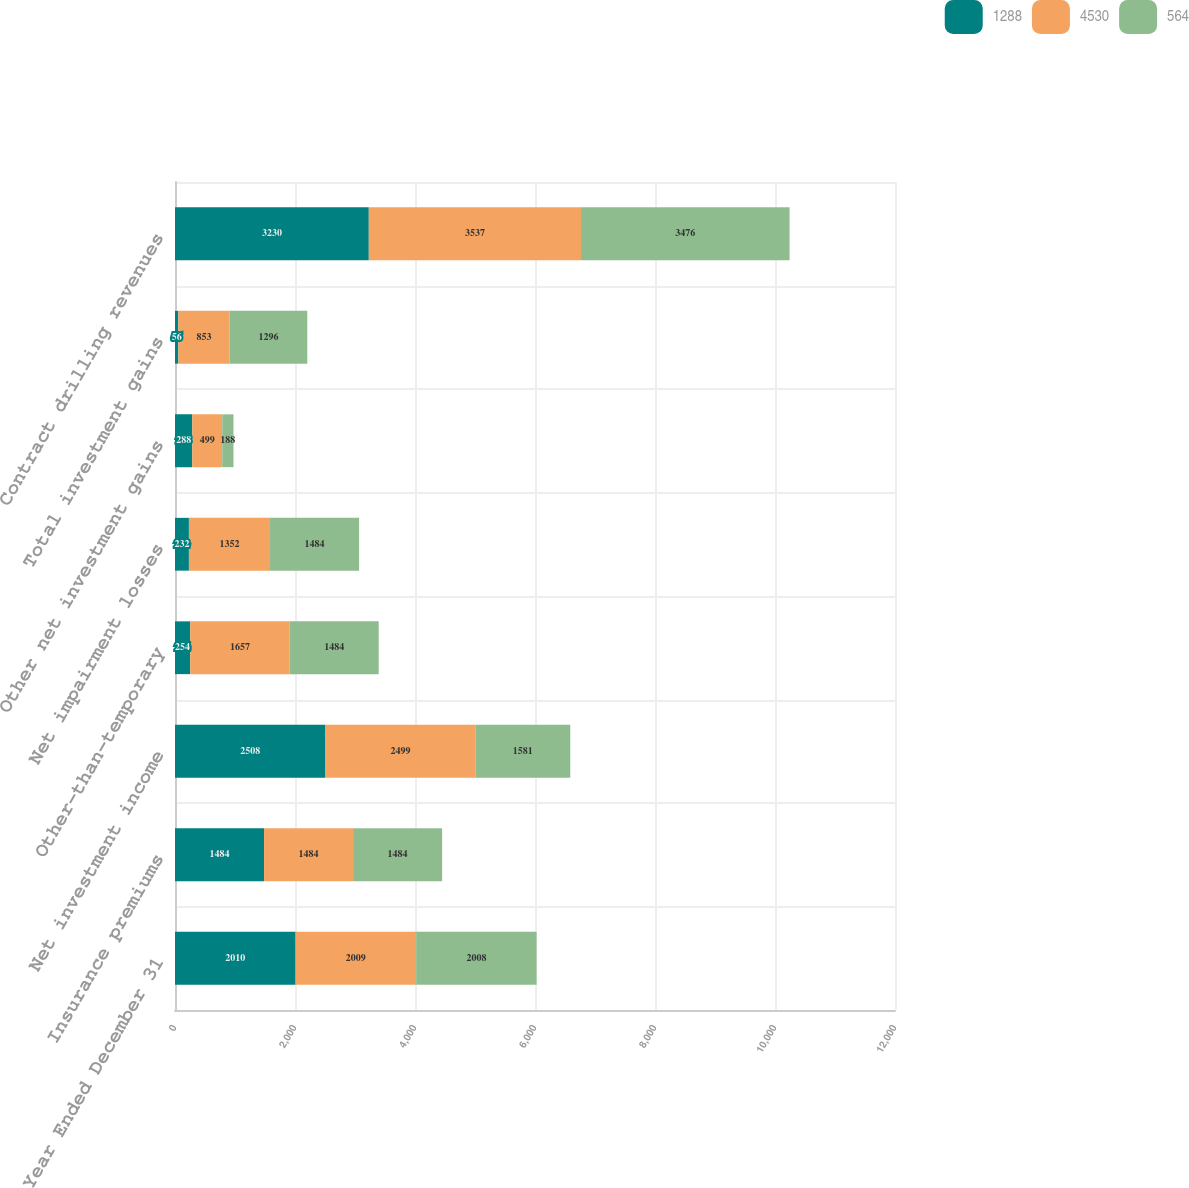Convert chart. <chart><loc_0><loc_0><loc_500><loc_500><stacked_bar_chart><ecel><fcel>Year Ended December 31<fcel>Insurance premiums<fcel>Net investment income<fcel>Other-than-temporary<fcel>Net impairment losses<fcel>Other net investment gains<fcel>Total investment gains<fcel>Contract drilling revenues<nl><fcel>1288<fcel>2010<fcel>1484<fcel>2508<fcel>254<fcel>232<fcel>288<fcel>56<fcel>3230<nl><fcel>4530<fcel>2009<fcel>1484<fcel>2499<fcel>1657<fcel>1352<fcel>499<fcel>853<fcel>3537<nl><fcel>564<fcel>2008<fcel>1484<fcel>1581<fcel>1484<fcel>1484<fcel>188<fcel>1296<fcel>3476<nl></chart> 